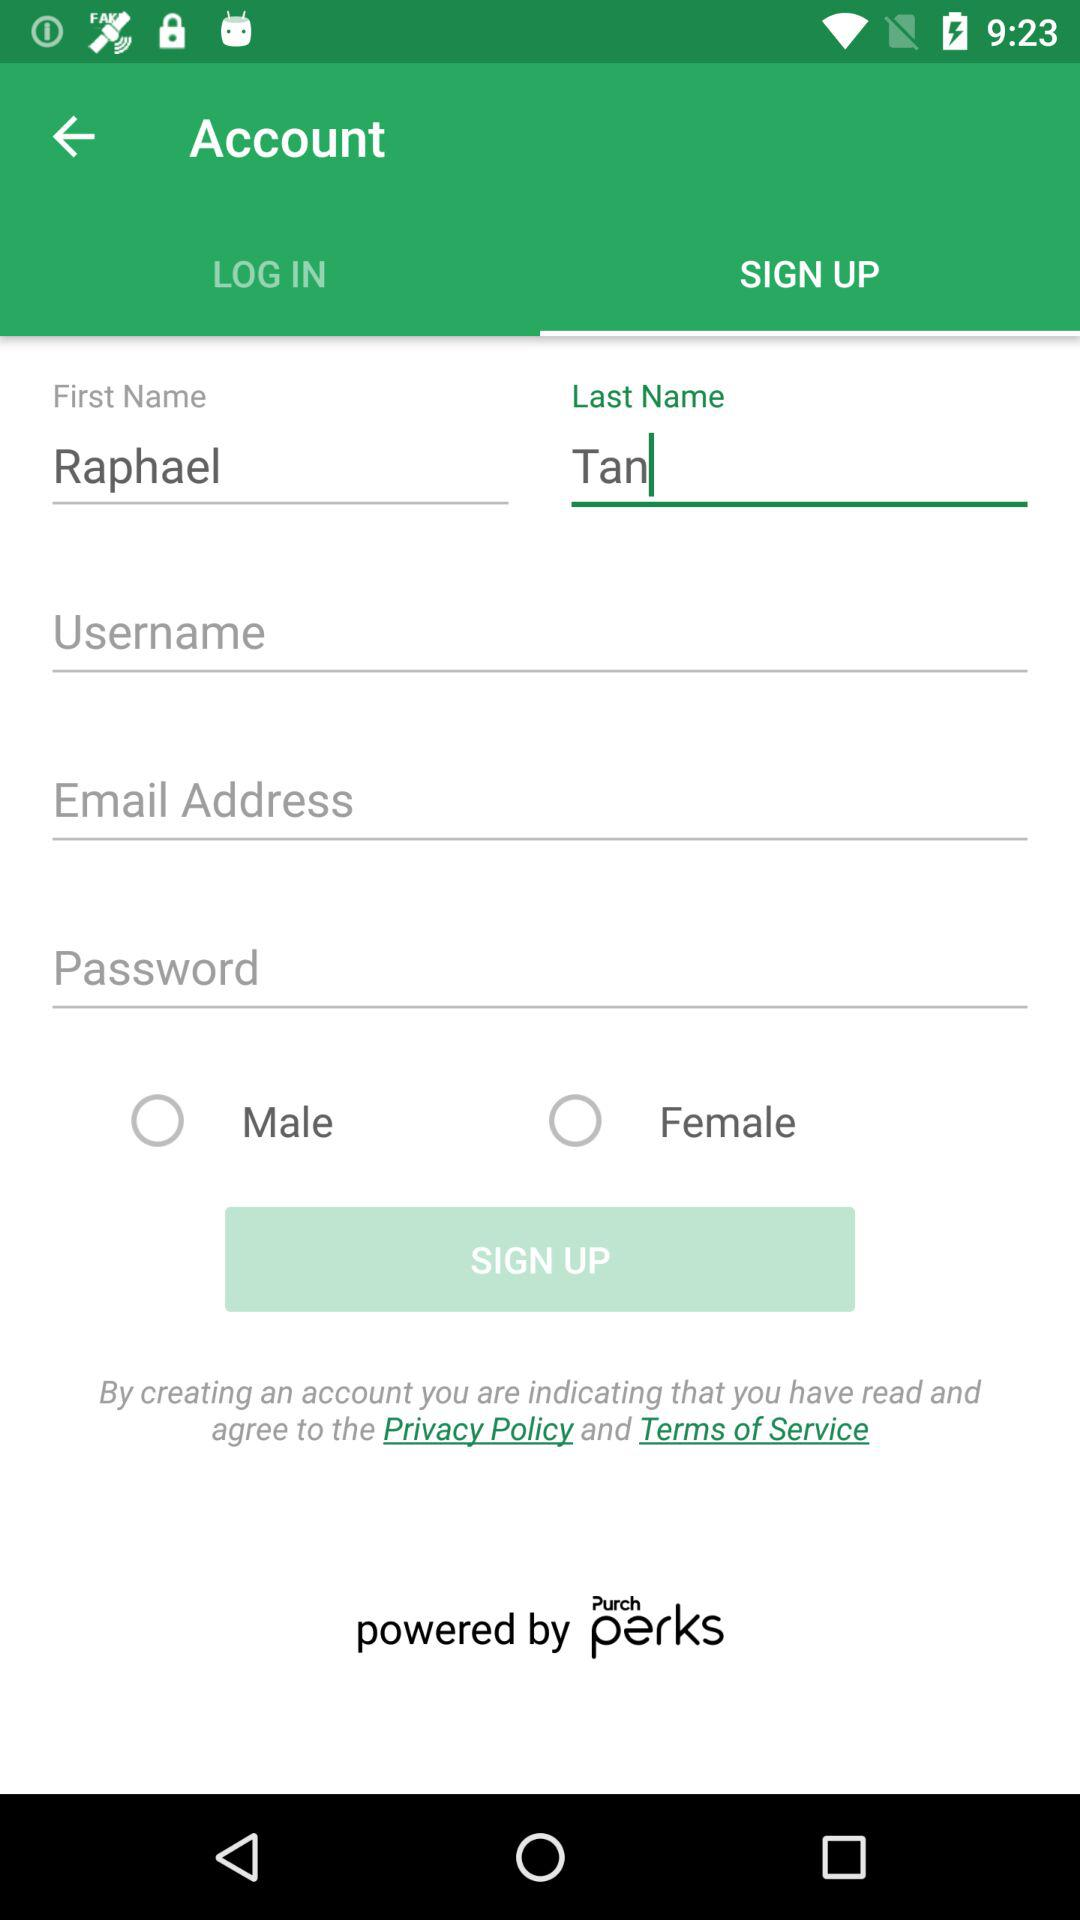What is the last name? The last name is Tan. 